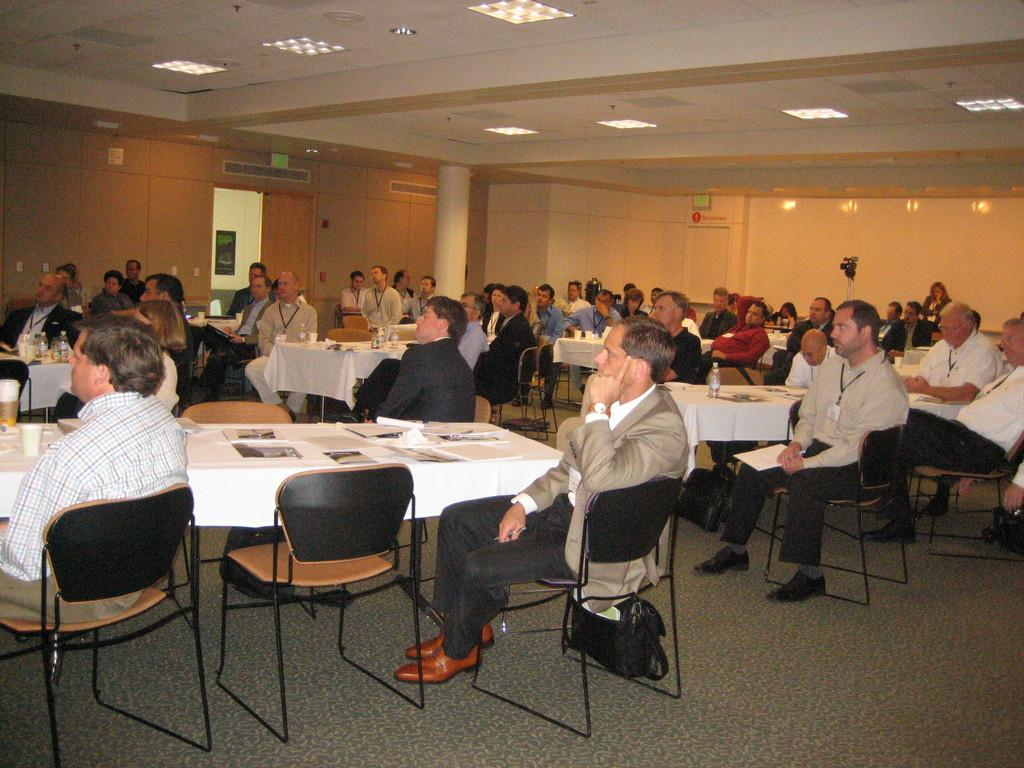What are the people in the image doing? There is a group of people sitting on chairs in the image. What is on the table in the image? There are papers on a table in the image. What can be seen in the background of the image? There is a wooden wall in the background of the image. What is the source of light in the image? There is a light visible at the top of the image. What type of maid is present in the image? There is no maid present in the image. 